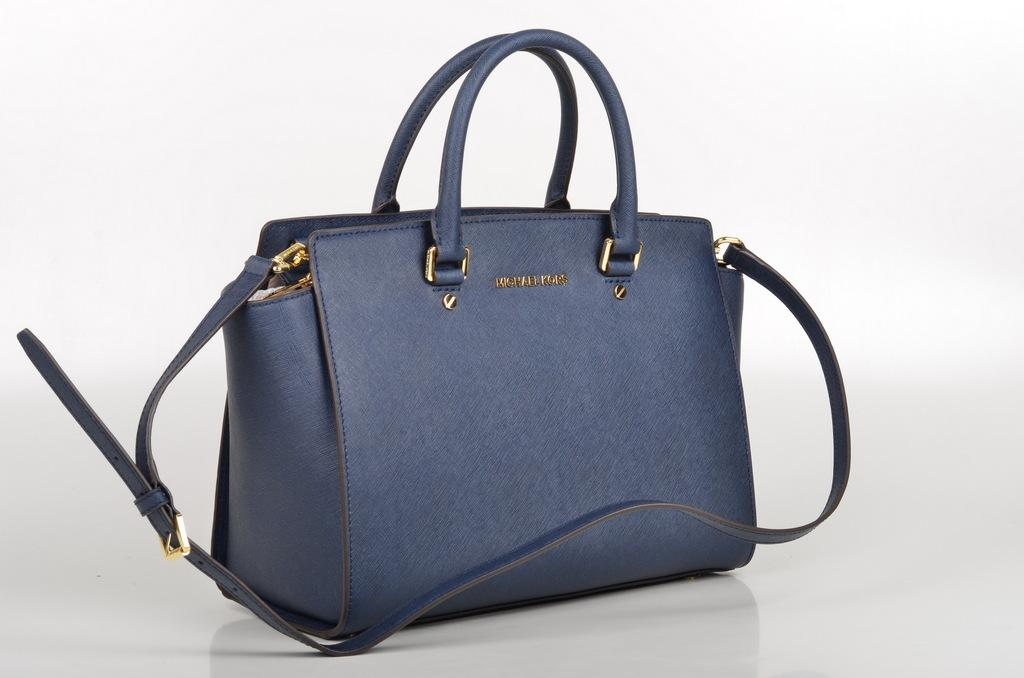What object can be seen in the image? There is a bag in the image. What is the color of the bag? The bag is blue in color. Is your uncle holding the bag in the image? There is no mention of an uncle in the image, nor is there any indication that someone is holding the bag. 